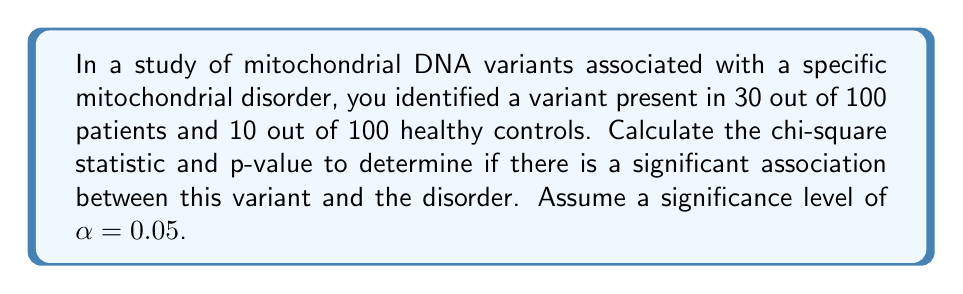What is the answer to this math problem? To determine the statistical significance of the genetic variant, we'll use the chi-square test of independence.

Step 1: Set up the contingency table
| Group    | Variant Present | Variant Absent | Total |
|----------|-----------------|----------------|-------|
| Patients | 30              | 70             | 100   |
| Controls | 10              | 90             | 100   |
| Total    | 40              | 160            | 200   |

Step 2: Calculate expected frequencies
For each cell: $E = \frac{(\text{row total}) \times (\text{column total})}{\text{grand total}}$

$E_{11} = \frac{100 \times 40}{200} = 20$
$E_{12} = \frac{100 \times 160}{200} = 80$
$E_{21} = \frac{100 \times 40}{200} = 20$
$E_{22} = \frac{100 \times 160}{200} = 80$

Step 3: Calculate the chi-square statistic
$$\chi^2 = \sum \frac{(O - E)^2}{E}$$

$\chi^2 = \frac{(30 - 20)^2}{20} + \frac{(70 - 80)^2}{80} + \frac{(10 - 20)^2}{20} + \frac{(90 - 80)^2}{80}$

$\chi^2 = 5 + 1.25 + 5 + 1.25 = 12.5$

Step 4: Determine degrees of freedom (df)
$df = (r - 1)(c - 1) = (2 - 1)(2 - 1) = 1$

Step 5: Find the critical value
For α = 0.05 and df = 1, the critical value is 3.841.

Step 6: Calculate the p-value
Using a chi-square distribution calculator or table, we find that for χ² = 12.5 and df = 1, p < 0.001.

Step 7: Interpret the results
Since χ² (12.5) > critical value (3.841) and p (< 0.001) < α (0.05), we reject the null hypothesis. There is a statistically significant association between the variant and the mitochondrial disorder.
Answer: χ² = 12.5, p < 0.001; statistically significant association 